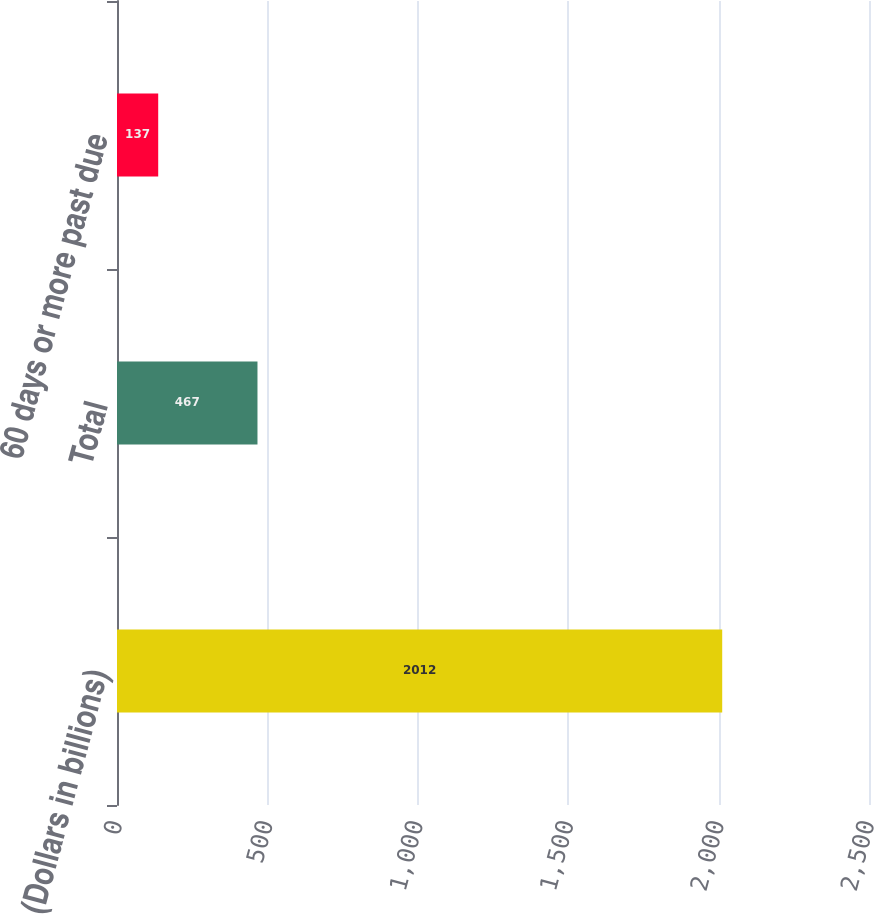Convert chart to OTSL. <chart><loc_0><loc_0><loc_500><loc_500><bar_chart><fcel>(Dollars in billions)<fcel>Total<fcel>60 days or more past due<nl><fcel>2012<fcel>467<fcel>137<nl></chart> 